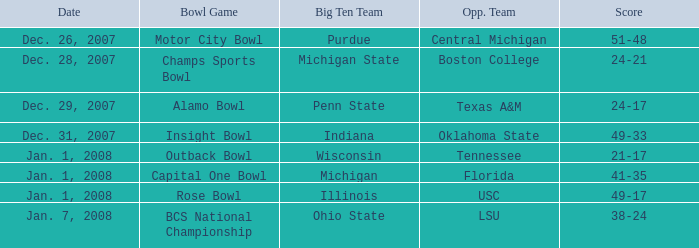What was the final score in the insight bowl? 49-33. Can you give me this table as a dict? {'header': ['Date', 'Bowl Game', 'Big Ten Team', 'Opp. Team', 'Score'], 'rows': [['Dec. 26, 2007', 'Motor City Bowl', 'Purdue', 'Central Michigan', '51-48'], ['Dec. 28, 2007', 'Champs Sports Bowl', 'Michigan State', 'Boston College', '24-21'], ['Dec. 29, 2007', 'Alamo Bowl', 'Penn State', 'Texas A&M', '24-17'], ['Dec. 31, 2007', 'Insight Bowl', 'Indiana', 'Oklahoma State', '49-33'], ['Jan. 1, 2008', 'Outback Bowl', 'Wisconsin', 'Tennessee', '21-17'], ['Jan. 1, 2008', 'Capital One Bowl', 'Michigan', 'Florida', '41-35'], ['Jan. 1, 2008', 'Rose Bowl', 'Illinois', 'USC', '49-17'], ['Jan. 7, 2008', 'BCS National Championship', 'Ohio State', 'LSU', '38-24']]} 